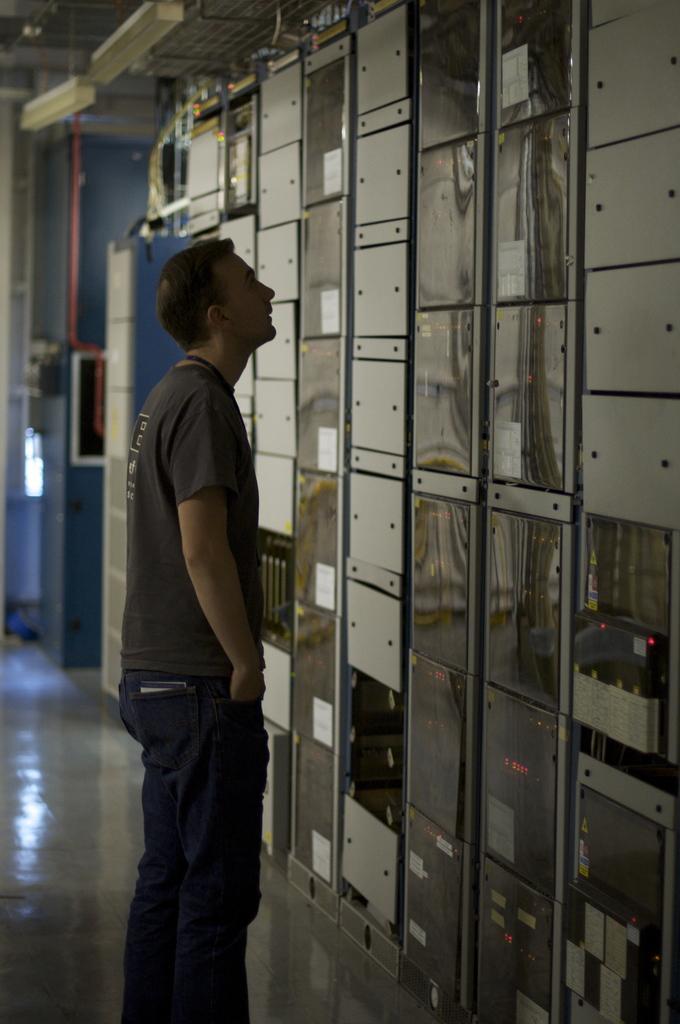How would you summarize this image in a sentence or two? In this image there is a man standing, and in the background there are machines. 